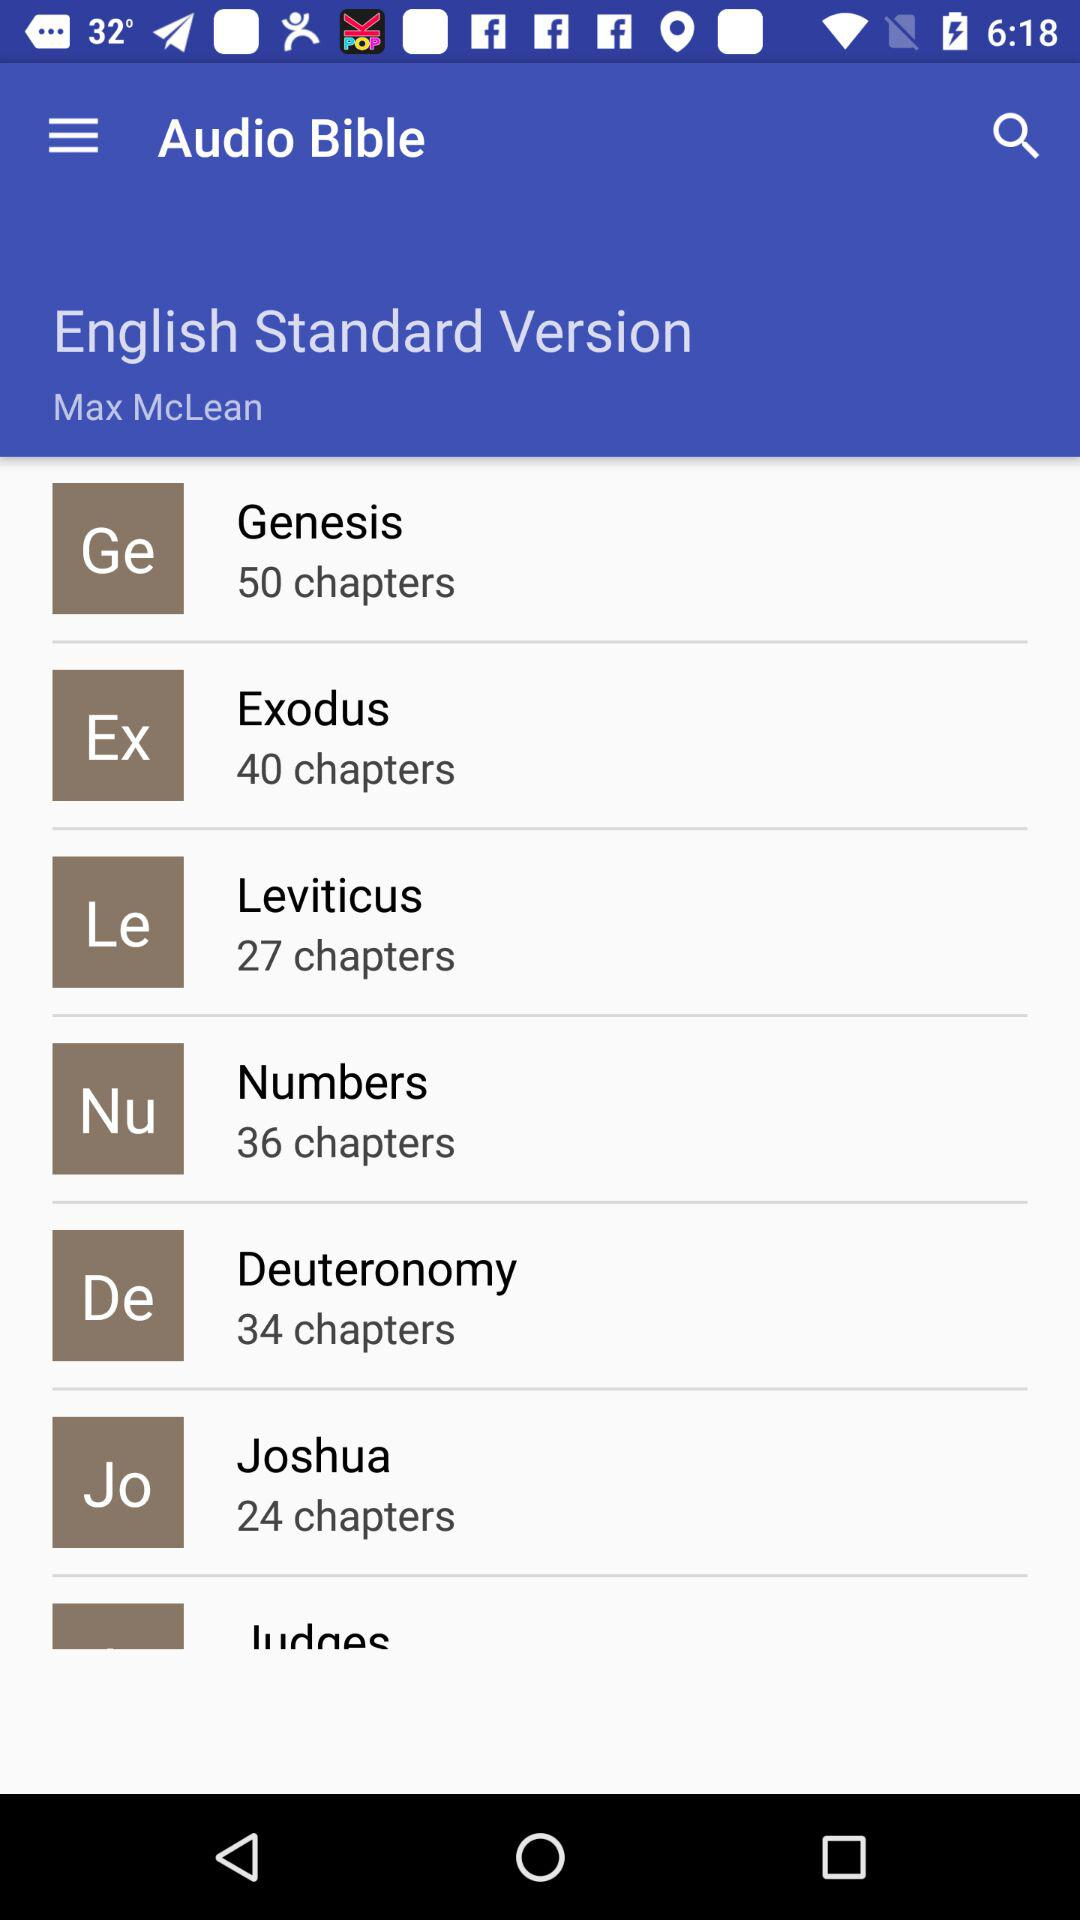On what topic are there 24 chapters available? The topic is "Joshua". 